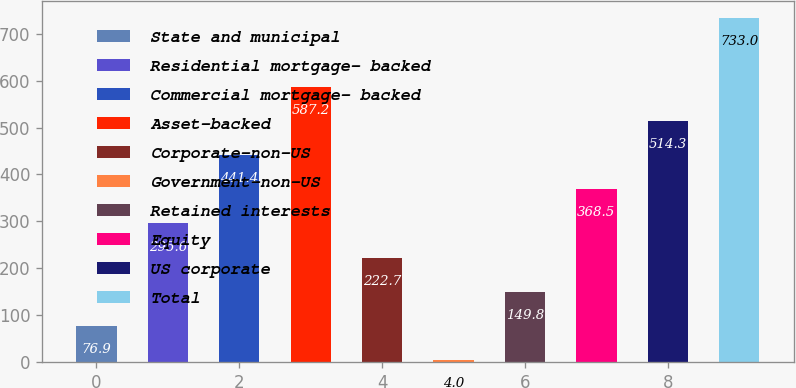Convert chart to OTSL. <chart><loc_0><loc_0><loc_500><loc_500><bar_chart><fcel>State and municipal<fcel>Residential mortgage- backed<fcel>Commercial mortgage- backed<fcel>Asset-backed<fcel>Corporate-non-US<fcel>Government-non-US<fcel>Retained interests<fcel>Equity<fcel>US corporate<fcel>Total<nl><fcel>76.9<fcel>295.6<fcel>441.4<fcel>587.2<fcel>222.7<fcel>4<fcel>149.8<fcel>368.5<fcel>514.3<fcel>733<nl></chart> 